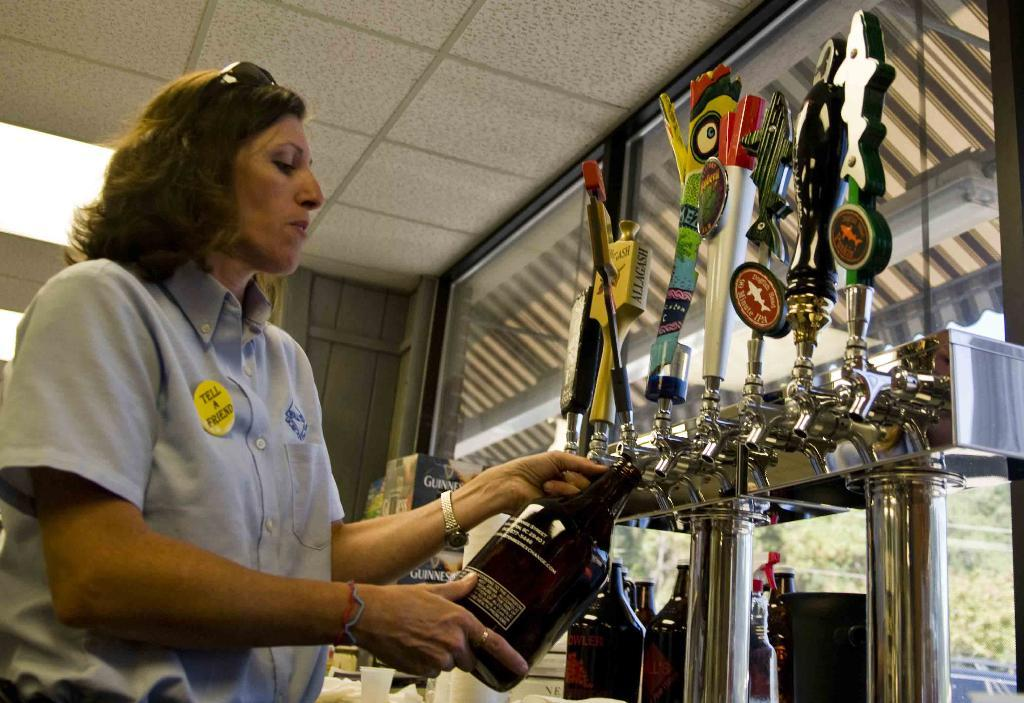Who is the main subject in the image? There is a woman in the image. What is the woman doing in the image? The woman is standing in the image. What is the woman holding in the image? The woman is holding a bottle in the image. What can be seen connected to the taps in the image? The taps are connected to a tank in the image. What type of dog is sitting on top of the woman in the image? There is no dog present in the image; the woman is standing and holding a bottle. 